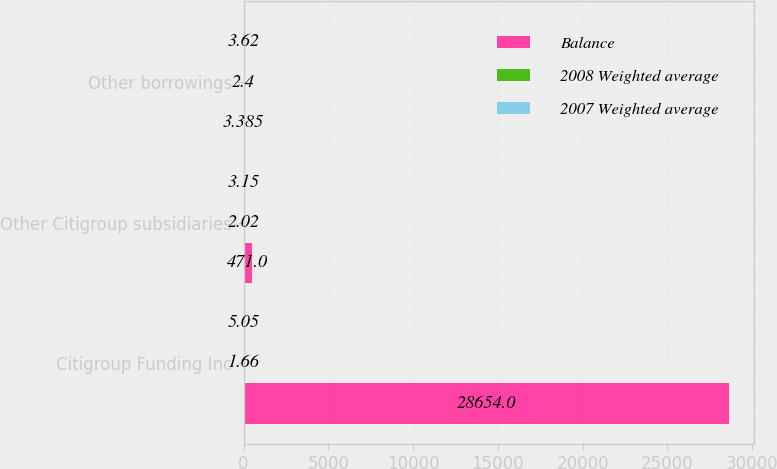Convert chart. <chart><loc_0><loc_0><loc_500><loc_500><stacked_bar_chart><ecel><fcel>Citigroup Funding Inc<fcel>Other Citigroup subsidiaries<fcel>Other borrowings<nl><fcel>Balance<fcel>28654<fcel>471<fcel>3.385<nl><fcel>2008 Weighted average<fcel>1.66<fcel>2.02<fcel>2.4<nl><fcel>2007 Weighted average<fcel>5.05<fcel>3.15<fcel>3.62<nl></chart> 